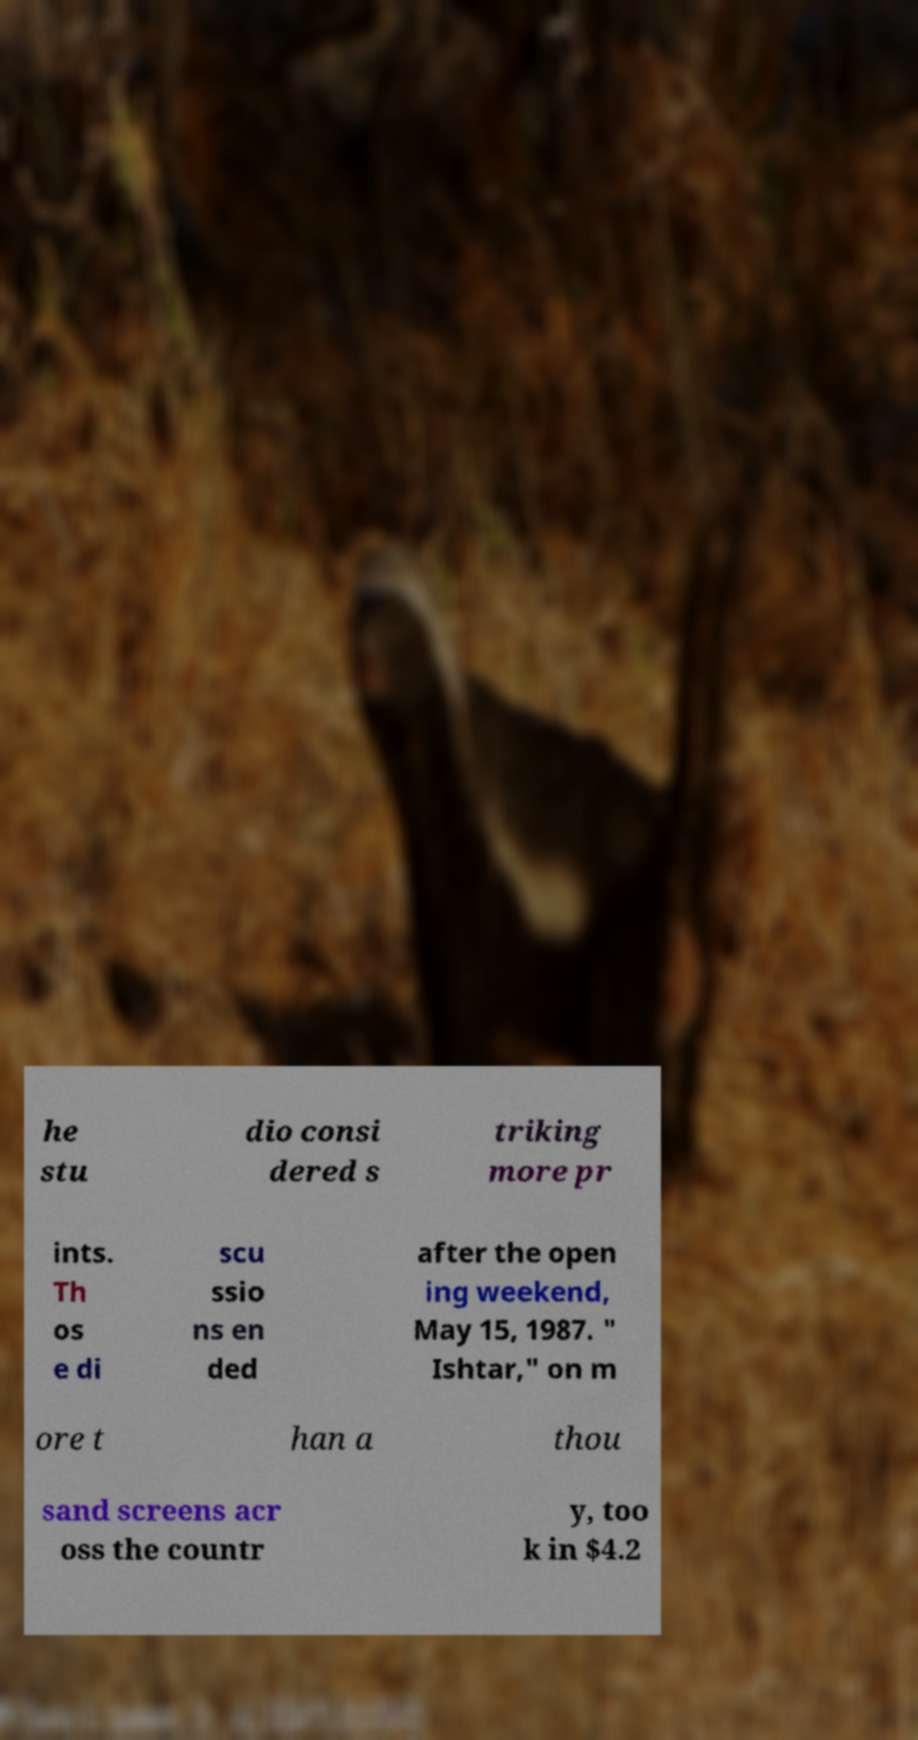Please identify and transcribe the text found in this image. he stu dio consi dered s triking more pr ints. Th os e di scu ssio ns en ded after the open ing weekend, May 15, 1987. " Ishtar," on m ore t han a thou sand screens acr oss the countr y, too k in $4.2 